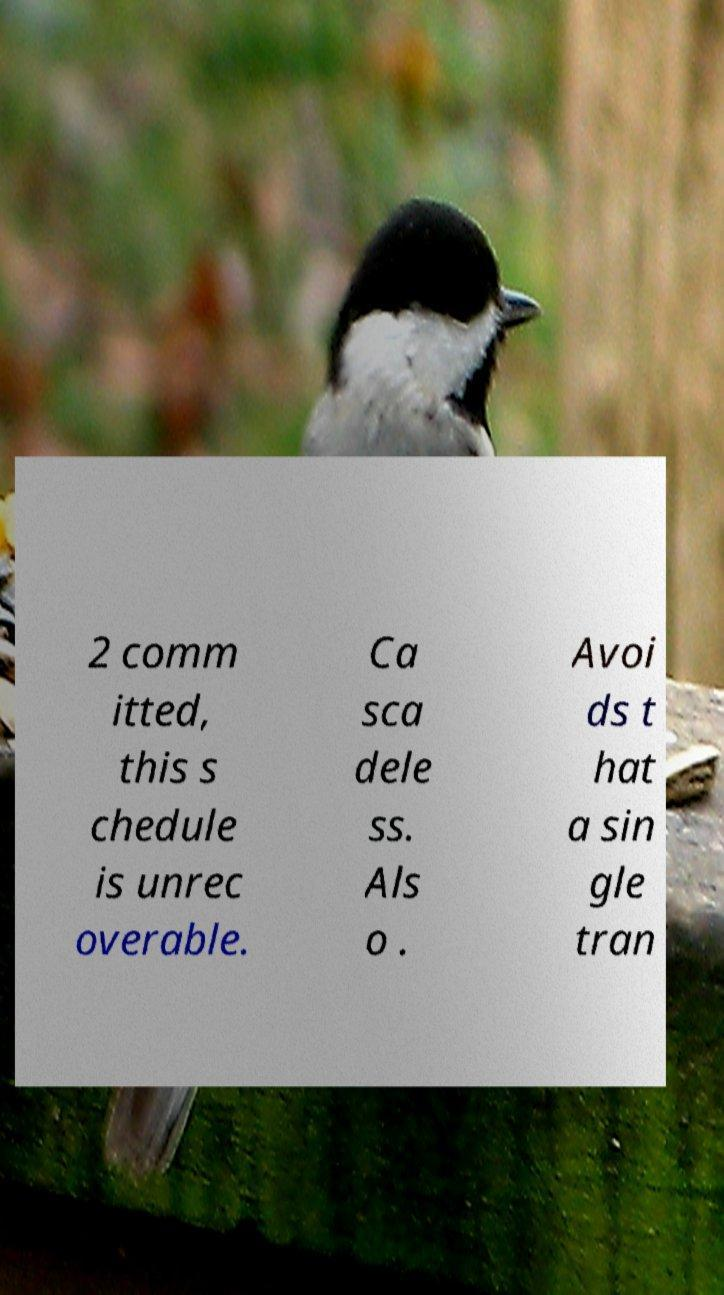Could you extract and type out the text from this image? 2 comm itted, this s chedule is unrec overable. Ca sca dele ss. Als o . Avoi ds t hat a sin gle tran 